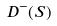<formula> <loc_0><loc_0><loc_500><loc_500>D ^ { - } ( S )</formula> 